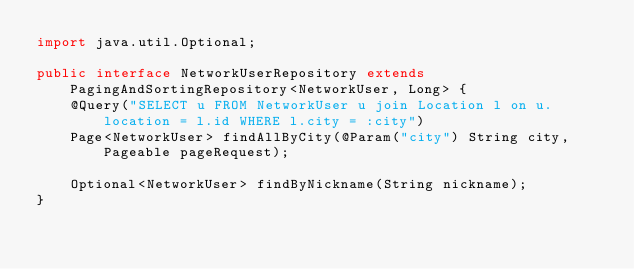Convert code to text. <code><loc_0><loc_0><loc_500><loc_500><_Java_>import java.util.Optional;

public interface NetworkUserRepository extends PagingAndSortingRepository<NetworkUser, Long> {
    @Query("SELECT u FROM NetworkUser u join Location l on u.location = l.id WHERE l.city = :city")
    Page<NetworkUser> findAllByCity(@Param("city") String city, Pageable pageRequest);

    Optional<NetworkUser> findByNickname(String nickname);
}
</code> 